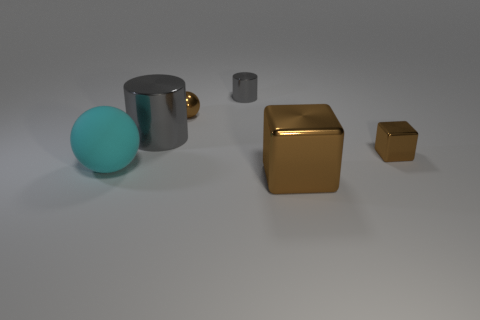Which of these objects appear to be reflective, and what might that suggest about their material? All objects in the image exhibit a degree of reflectivity, which suggests they have a metallic finish. The silver mug and the two cubes reflect light and their surroundings, indicating they are probably made of metal. The reflection and shininess are characteristic of metal's smooth and glossy surface properties. 